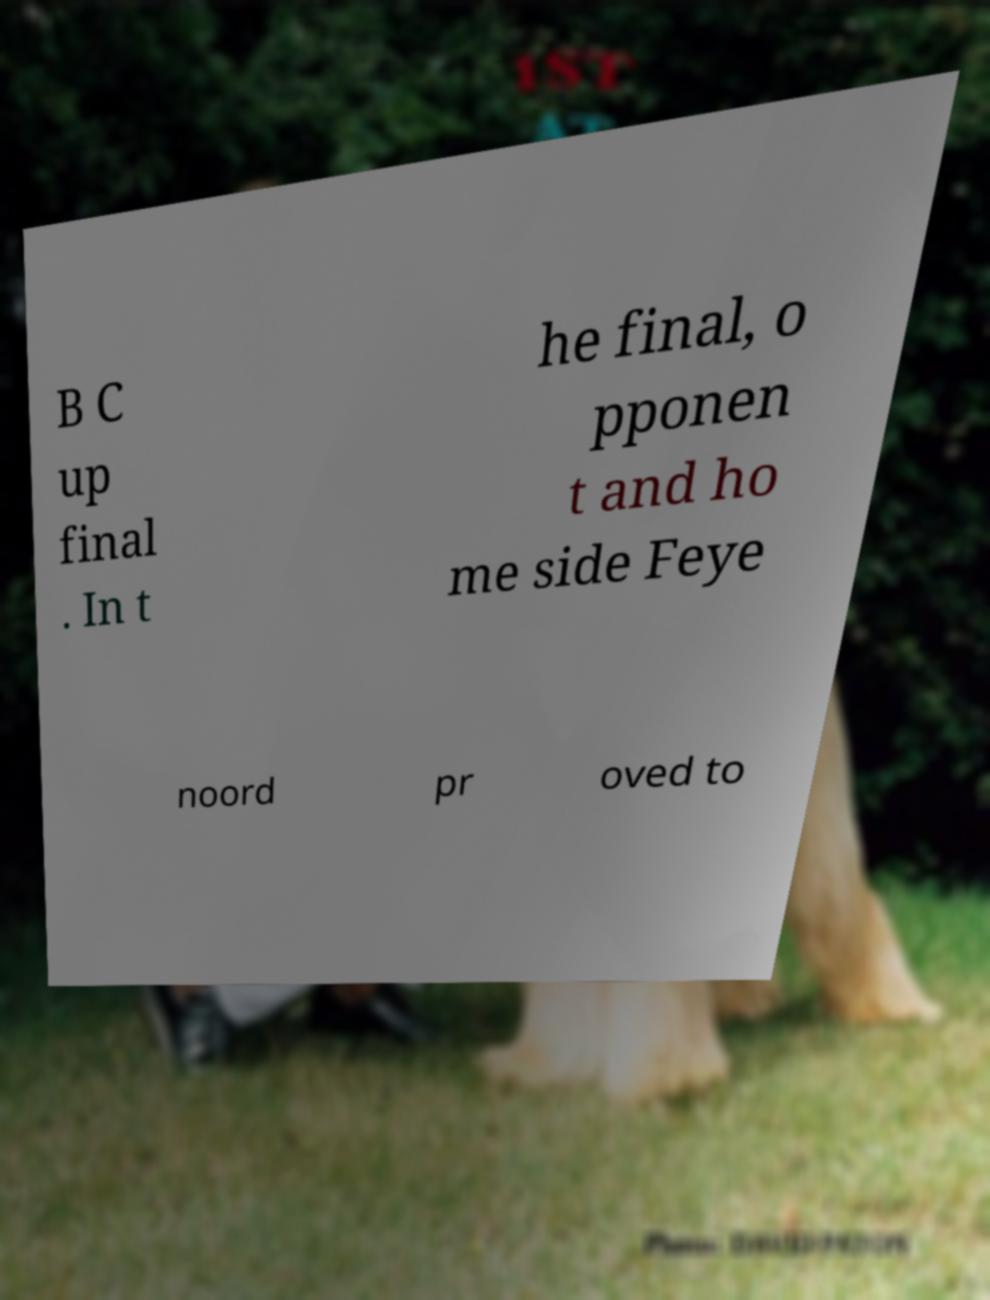For documentation purposes, I need the text within this image transcribed. Could you provide that? B C up final . In t he final, o pponen t and ho me side Feye noord pr oved to 